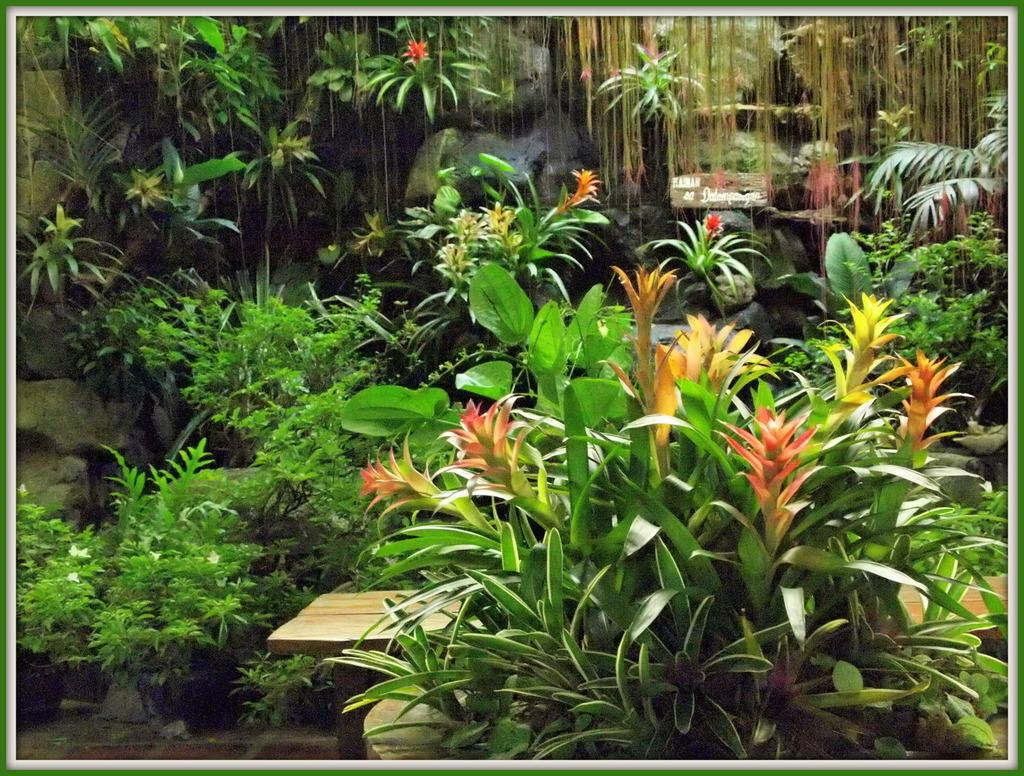What type of plants are present in the image? The flowers are on plants in the image. What color are the flowers? The flowers are red. Where is the bench located in relation to the plants? The bench is between the plants in the image. What can be seen in the background of the image? There are rocks in the background of the image. What language is being spoken by the flowers in the image? There is no indication in the image that the flowers are speaking any language. 